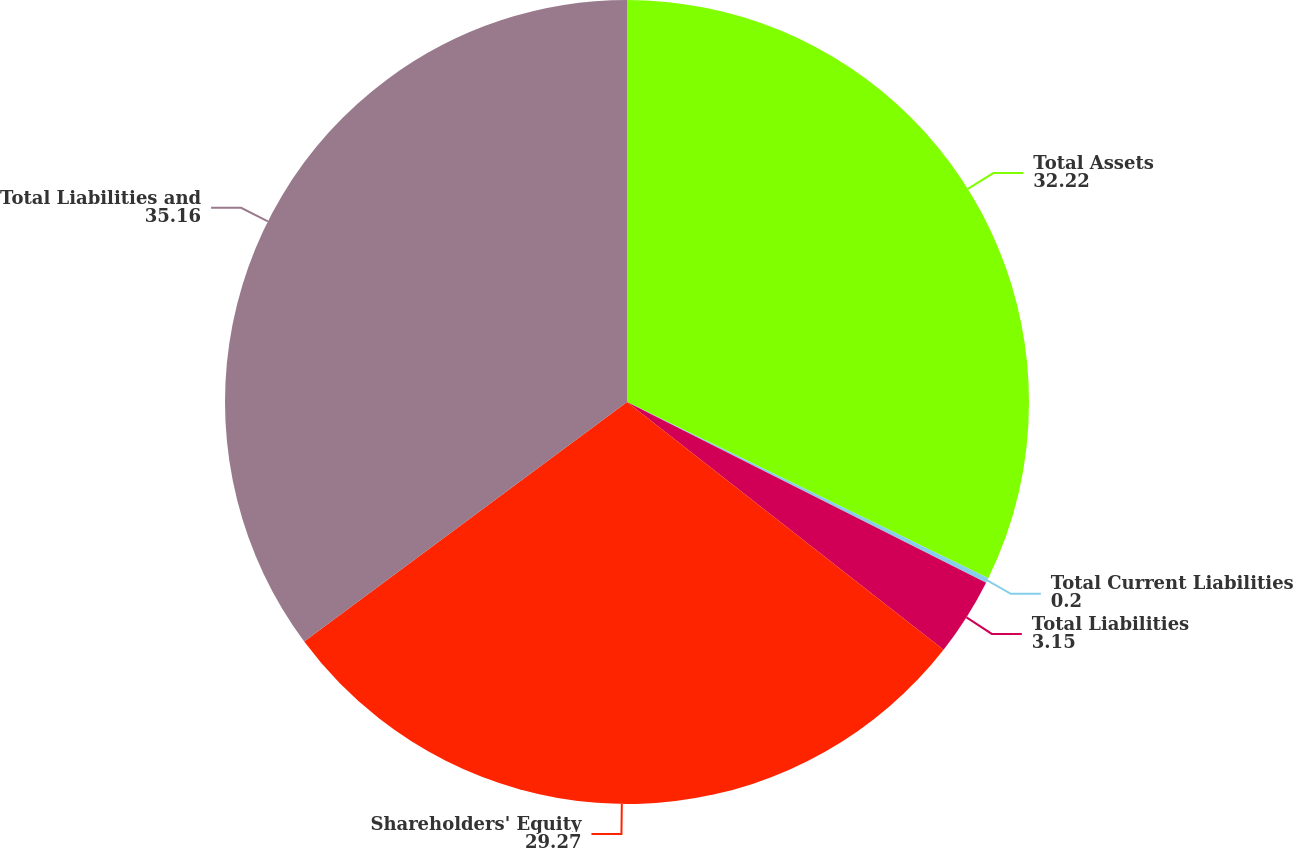Convert chart to OTSL. <chart><loc_0><loc_0><loc_500><loc_500><pie_chart><fcel>Total Assets<fcel>Total Current Liabilities<fcel>Total Liabilities<fcel>Shareholders' Equity<fcel>Total Liabilities and<nl><fcel>32.22%<fcel>0.2%<fcel>3.15%<fcel>29.27%<fcel>35.16%<nl></chart> 